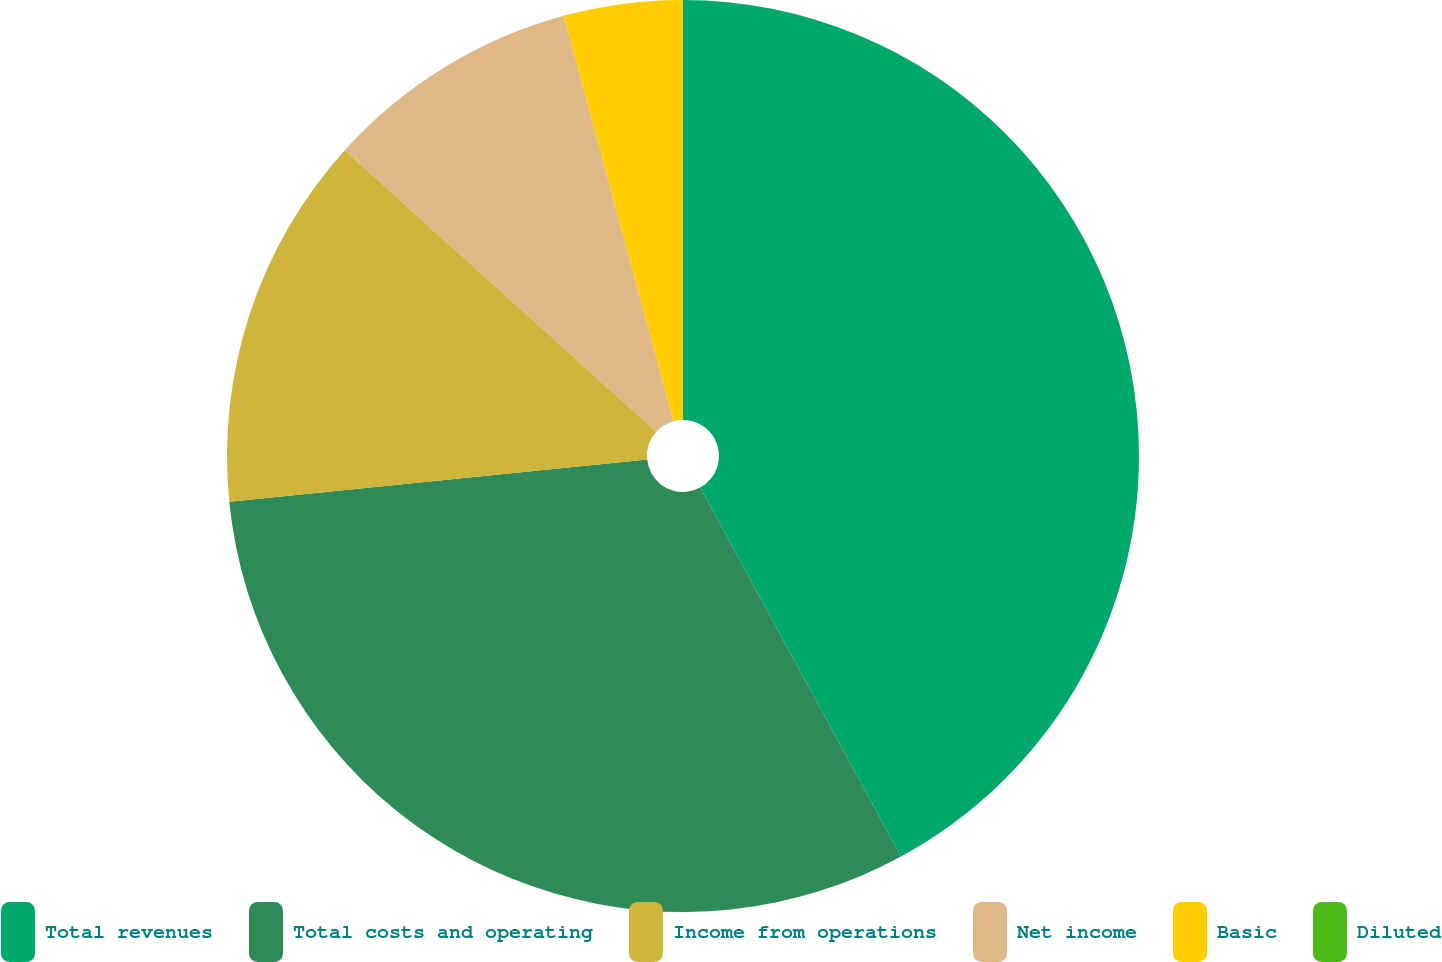Convert chart to OTSL. <chart><loc_0><loc_0><loc_500><loc_500><pie_chart><fcel>Total revenues<fcel>Total costs and operating<fcel>Income from operations<fcel>Net income<fcel>Basic<fcel>Diluted<nl><fcel>42.07%<fcel>31.34%<fcel>13.3%<fcel>9.09%<fcel>4.21%<fcel>0.0%<nl></chart> 